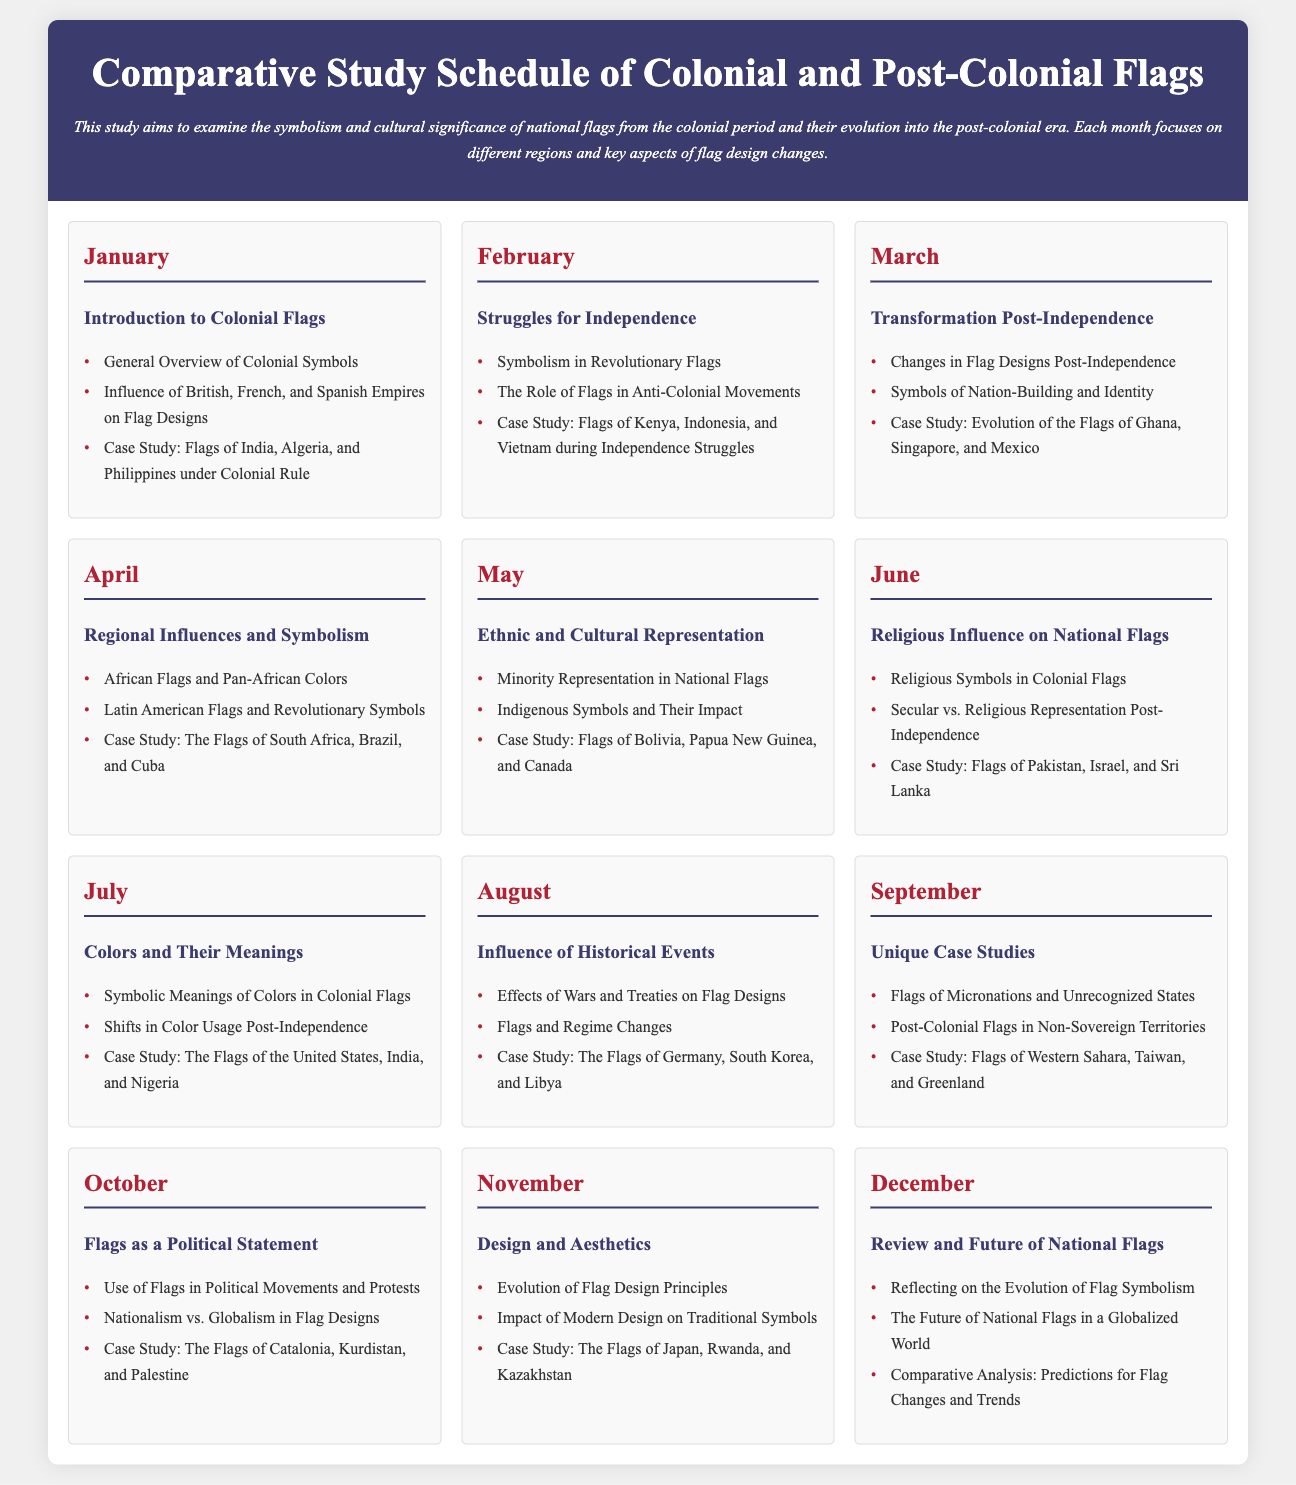What is the title of the document? The title is prominently displayed in the header section of the document.
Answer: Comparative Study Schedule of Colonial and Post-Colonial Flags How many months are covered in the study schedule? Each month is represented as a distinct section in the calendar format.
Answer: Twelve What is the focus of the study in January? The title for January indicates the main topic of that month.
Answer: Introduction to Colonial Flags Which case study is featured in June? The case study for June is listed under the relevant topic heading.
Answer: Flags of Pakistan, Israel, and Sri Lanka What color is used for the month headings in the calendar? The CSS styling specifies the color used for the headings.
Answer: Red What month covers the topic of ethnic and cultural representation? The month is noted for its specific topic based on its section header.
Answer: May Which two countries are included in the case study for March? The case study for March lists specific countries found under its heading.
Answer: Ghana, Singapore What theme is explored in the month of October? The theme for October is clearly stated in its monthly header.
Answer: Flags as a Political Statement In which month is the review of national flags discussed? The month is specified in the document under its corresponding title.
Answer: December 